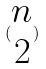Convert formula to latex. <formula><loc_0><loc_0><loc_500><loc_500>( \begin{matrix} n \\ 2 \end{matrix} )</formula> 